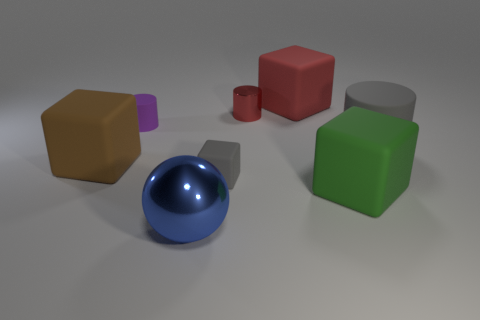Subtract all big red cubes. How many cubes are left? 3 Add 1 big yellow metallic balls. How many objects exist? 9 Subtract all cylinders. How many objects are left? 5 Subtract 1 cylinders. How many cylinders are left? 2 Add 5 tiny rubber objects. How many tiny rubber objects are left? 7 Add 3 gray rubber cylinders. How many gray rubber cylinders exist? 4 Subtract all gray cylinders. How many cylinders are left? 2 Subtract 0 green spheres. How many objects are left? 8 Subtract all cyan cylinders. Subtract all yellow blocks. How many cylinders are left? 3 Subtract all brown cubes. How many gray cylinders are left? 1 